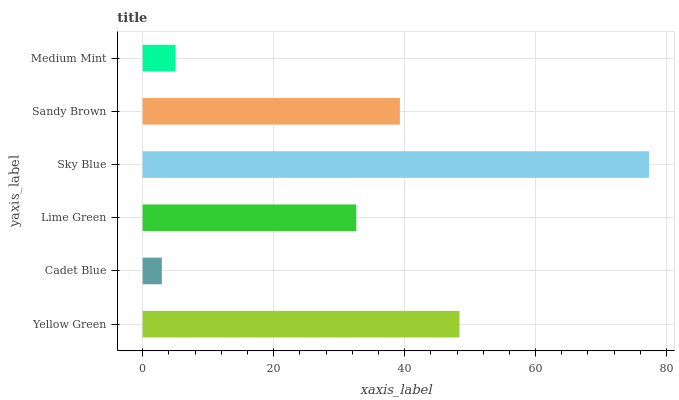Is Cadet Blue the minimum?
Answer yes or no. Yes. Is Sky Blue the maximum?
Answer yes or no. Yes. Is Lime Green the minimum?
Answer yes or no. No. Is Lime Green the maximum?
Answer yes or no. No. Is Lime Green greater than Cadet Blue?
Answer yes or no. Yes. Is Cadet Blue less than Lime Green?
Answer yes or no. Yes. Is Cadet Blue greater than Lime Green?
Answer yes or no. No. Is Lime Green less than Cadet Blue?
Answer yes or no. No. Is Sandy Brown the high median?
Answer yes or no. Yes. Is Lime Green the low median?
Answer yes or no. Yes. Is Sky Blue the high median?
Answer yes or no. No. Is Yellow Green the low median?
Answer yes or no. No. 